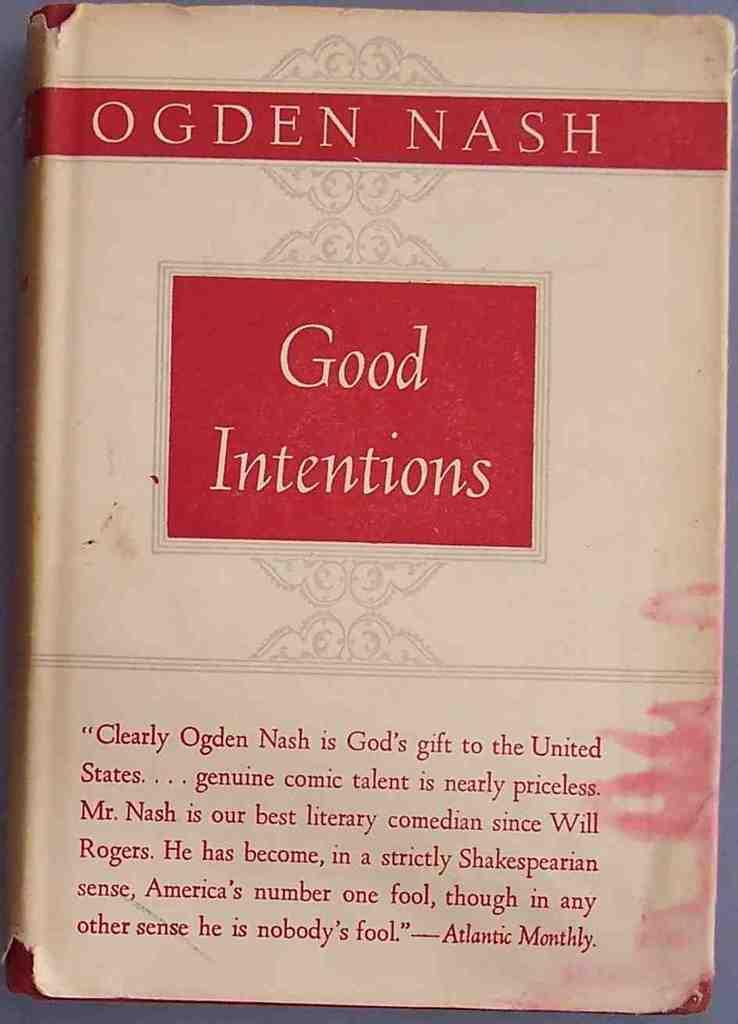Provide a one-sentence caption for the provided image. The 'Good Intentions' book by author Ogden Nash displays a quote from Atlantic Monthly on the front. 